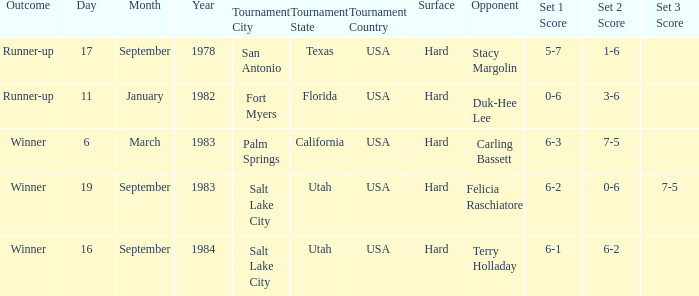What was the outcome of the match against Stacy Margolin? Runner-up. 